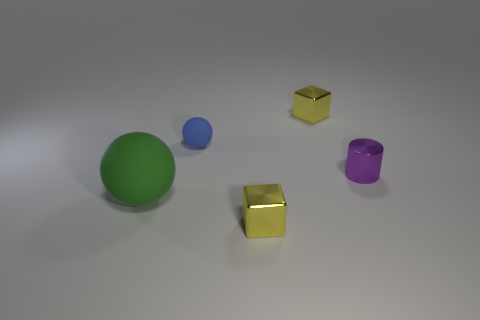Can you tell me the colors of the objects shown? Certainly! There are four objects each with its own distinct color: a green ball, a blue ball, a gold cube, and a purple cylinder. 